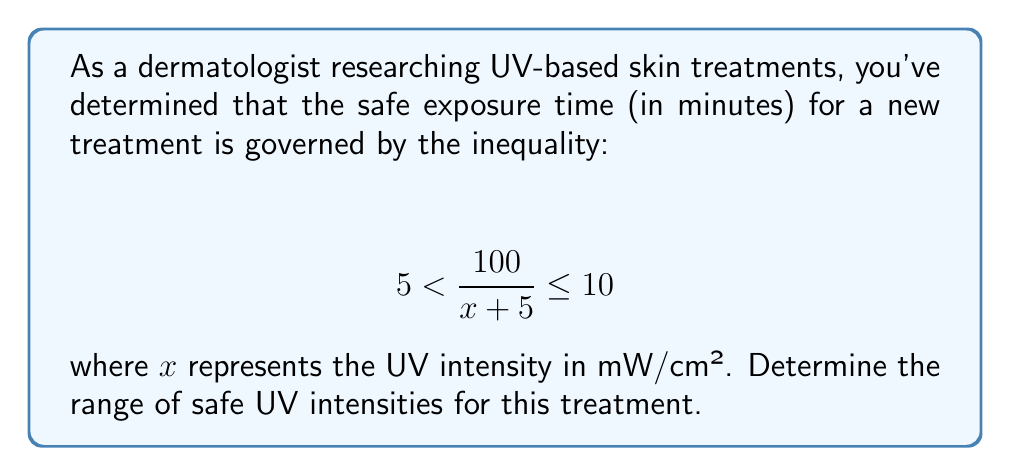Give your solution to this math problem. To solve this problem, we need to manipulate the given inequality:

$$ 5 < \frac{100}{x + 5} \leq 10 $$

Let's solve each part of the inequality separately:

1) For the left side: $5 < \frac{100}{x + 5}$
   
   Multiply both sides by $(x + 5)$:
   $5(x + 5) < 100$
   $5x + 25 < 100$
   $5x < 75$
   $x < 15$

2) For the right side: $\frac{100}{x + 5} \leq 10$
   
   Multiply both sides by $(x + 5)$:
   $100 \leq 10(x + 5)$
   $100 \leq 10x + 50$
   $50 \leq 10x$
   $5 \leq x$

Combining these results, we get:

$$ 5 \leq x < 15 $$

This means the safe UV intensity range is from 5 mW/cm² (inclusive) to 15 mW/cm² (exclusive).
Answer: The safe UV intensity range for the treatment is $[5, 15)$ mW/cm², or $5 \leq x < 15$ mW/cm². 